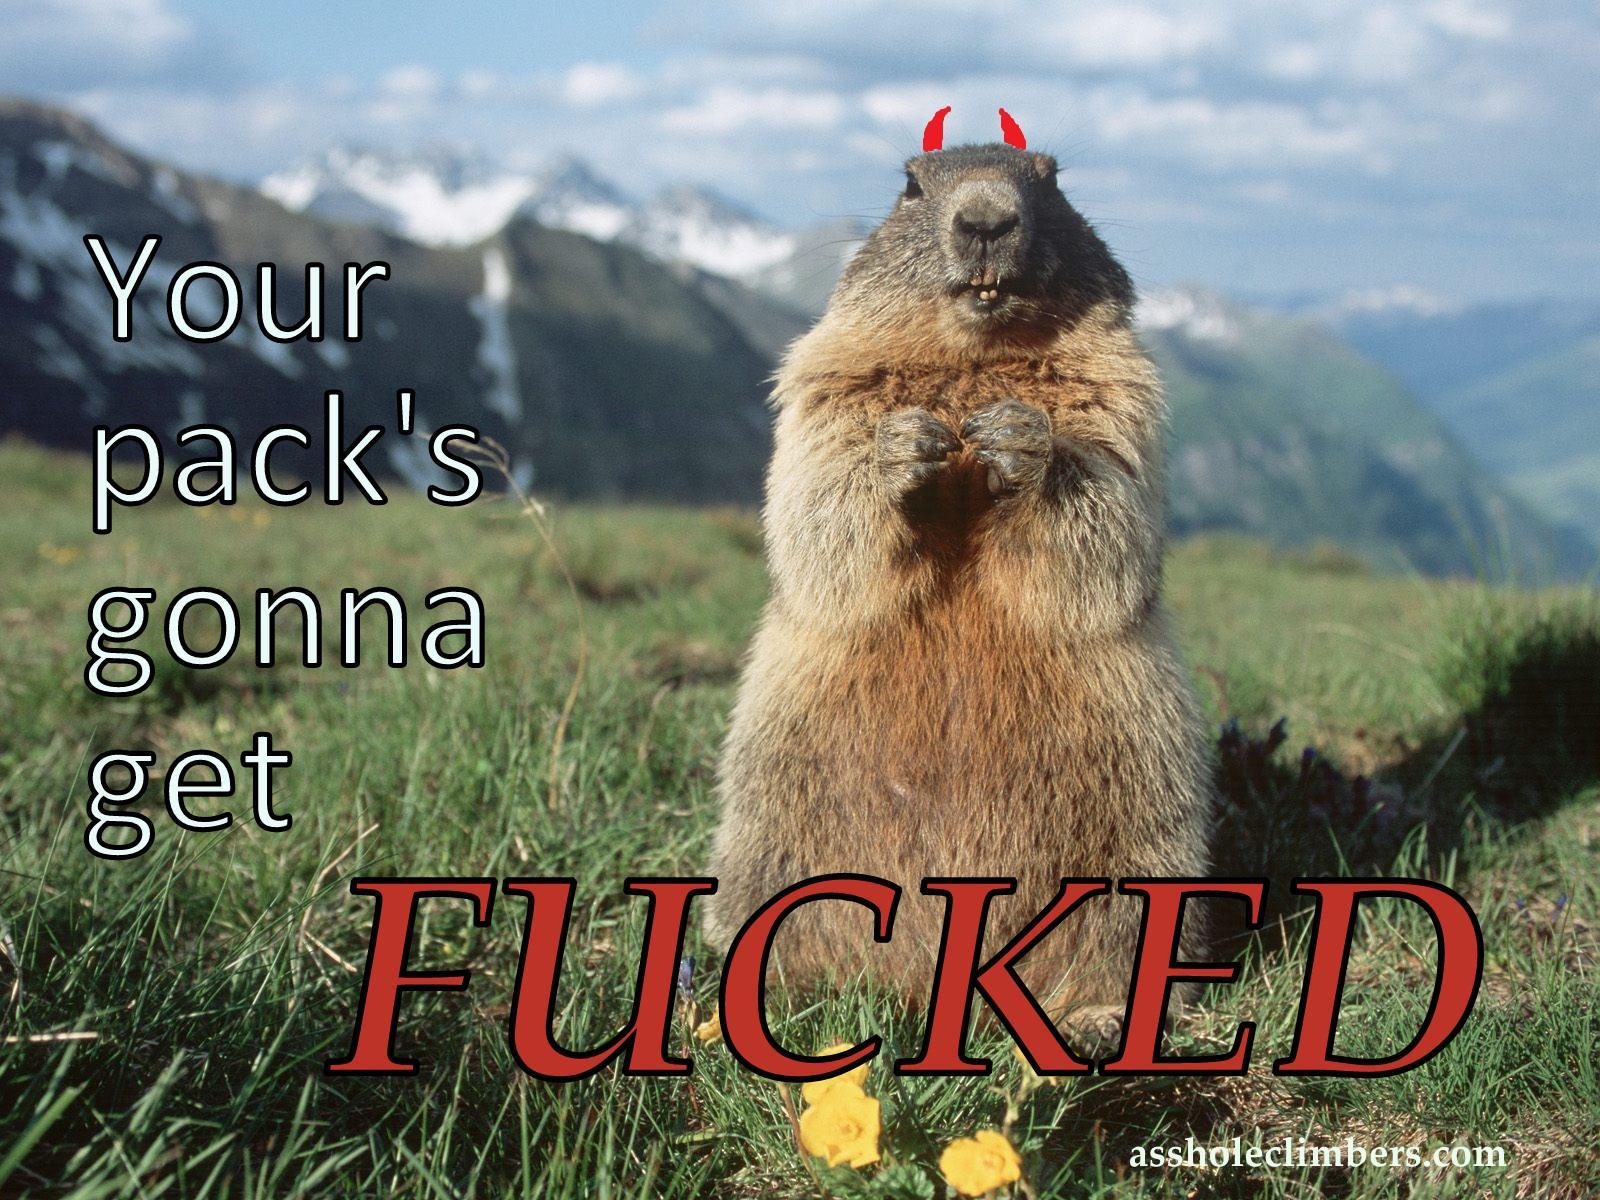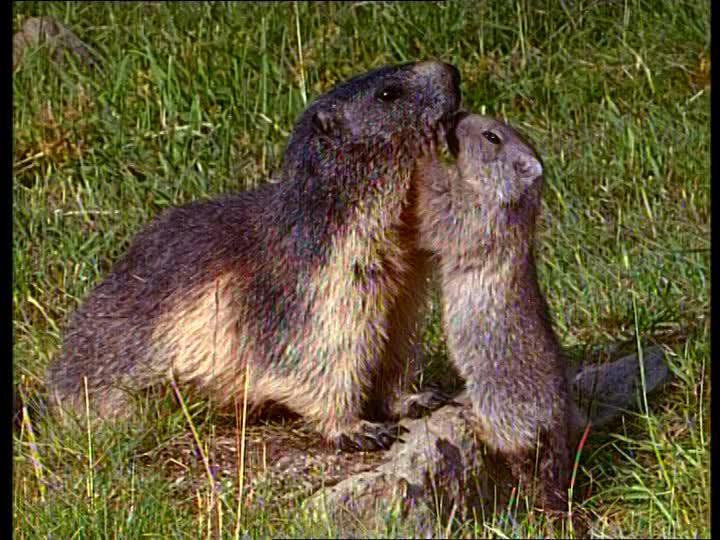The first image is the image on the left, the second image is the image on the right. For the images shown, is this caption "An image contains more than one rodent." true? Answer yes or no. Yes. 